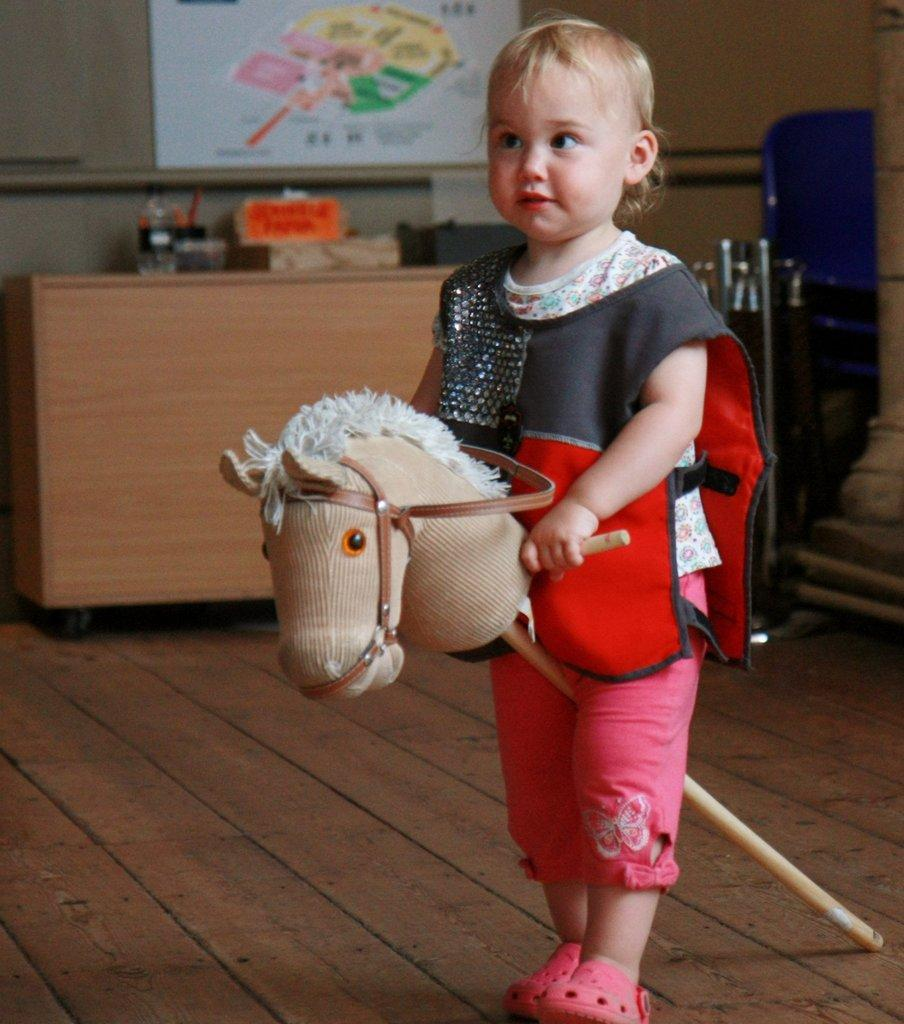What is the main subject of the image? There is a baby in the image. What is the baby doing in the image? The baby is standing. What is the baby holding in the image? The baby is holding something. Can you describe the brown object in the image? There are objects on a brown color object in the image. What is attached to the wall in the image? A board is attached to the wall. How does the baby contribute to the division of labor in the image? The image does not depict any division of labor, and the baby is not performing any specific task related to labor. 